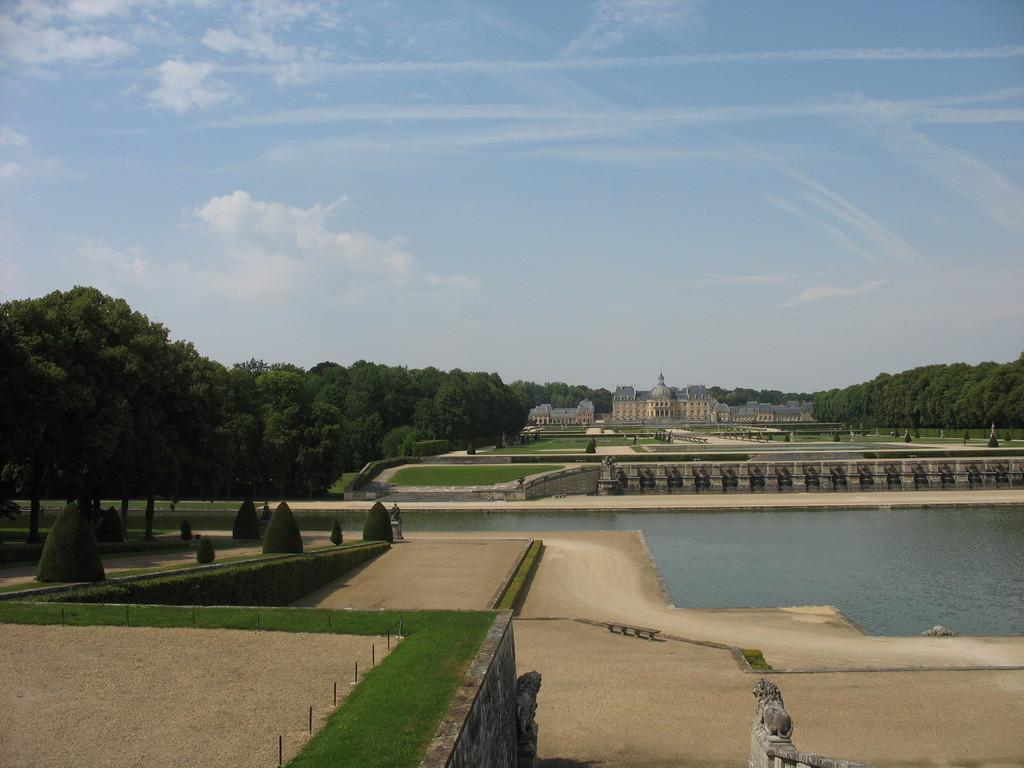What can be seen in the foreground of the image? In the foreground of the image, there is land, grass, trees, and water. Can you describe the vegetation in the foreground? The vegetation in the foreground includes trees and grass. What is visible in the background of the image? In the background of the image, there are trees, grasslands, a building, and the sky. How many types of natural landscapes are visible in the image? Two types of natural landscapes are visible: water and grasslands. Where is the rose located in the image? There is no rose present in the image. Can you describe the volleyball game happening in the background of the image? There is no volleyball game present in the image; it features natural landscapes and a building in the background. 